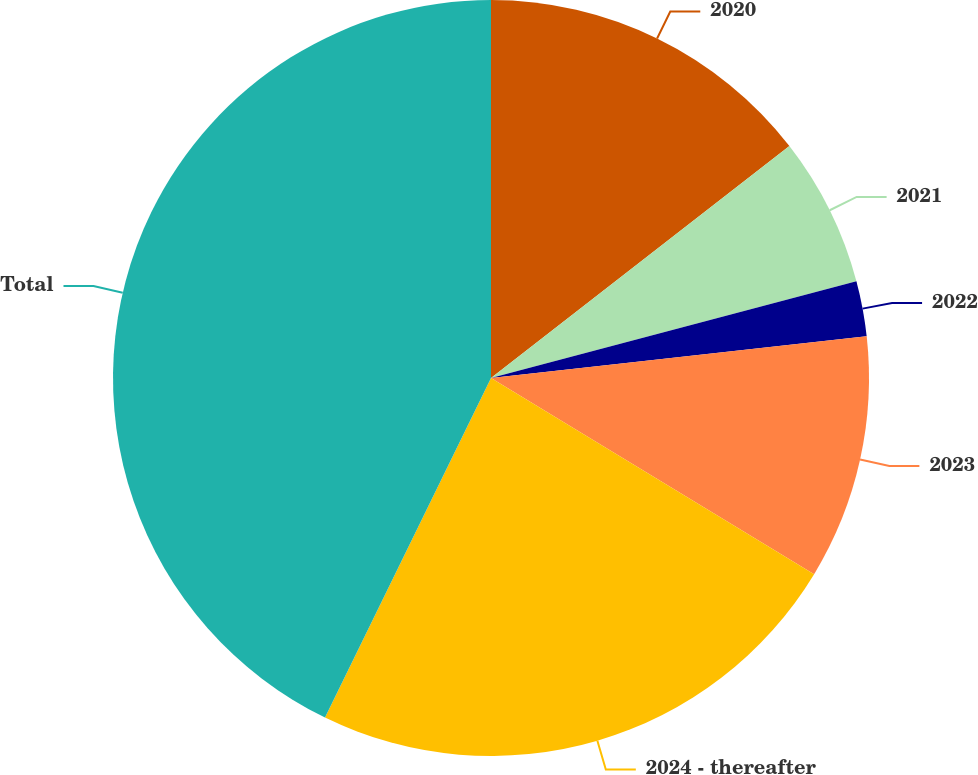Convert chart to OTSL. <chart><loc_0><loc_0><loc_500><loc_500><pie_chart><fcel>2020<fcel>2021<fcel>2022<fcel>2023<fcel>2024 - thereafter<fcel>Total<nl><fcel>14.48%<fcel>6.4%<fcel>2.36%<fcel>10.44%<fcel>23.55%<fcel>42.76%<nl></chart> 